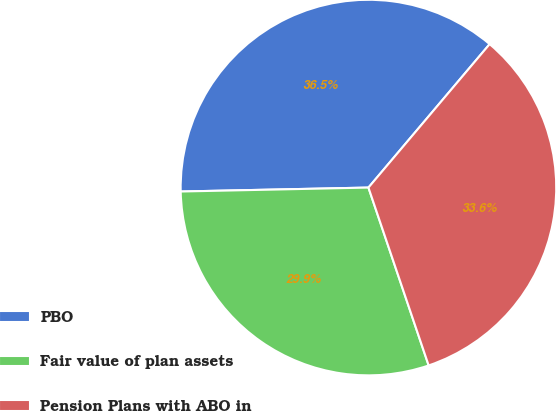Convert chart. <chart><loc_0><loc_0><loc_500><loc_500><pie_chart><fcel>PBO<fcel>Fair value of plan assets<fcel>Pension Plans with ABO in<nl><fcel>36.5%<fcel>29.86%<fcel>33.64%<nl></chart> 